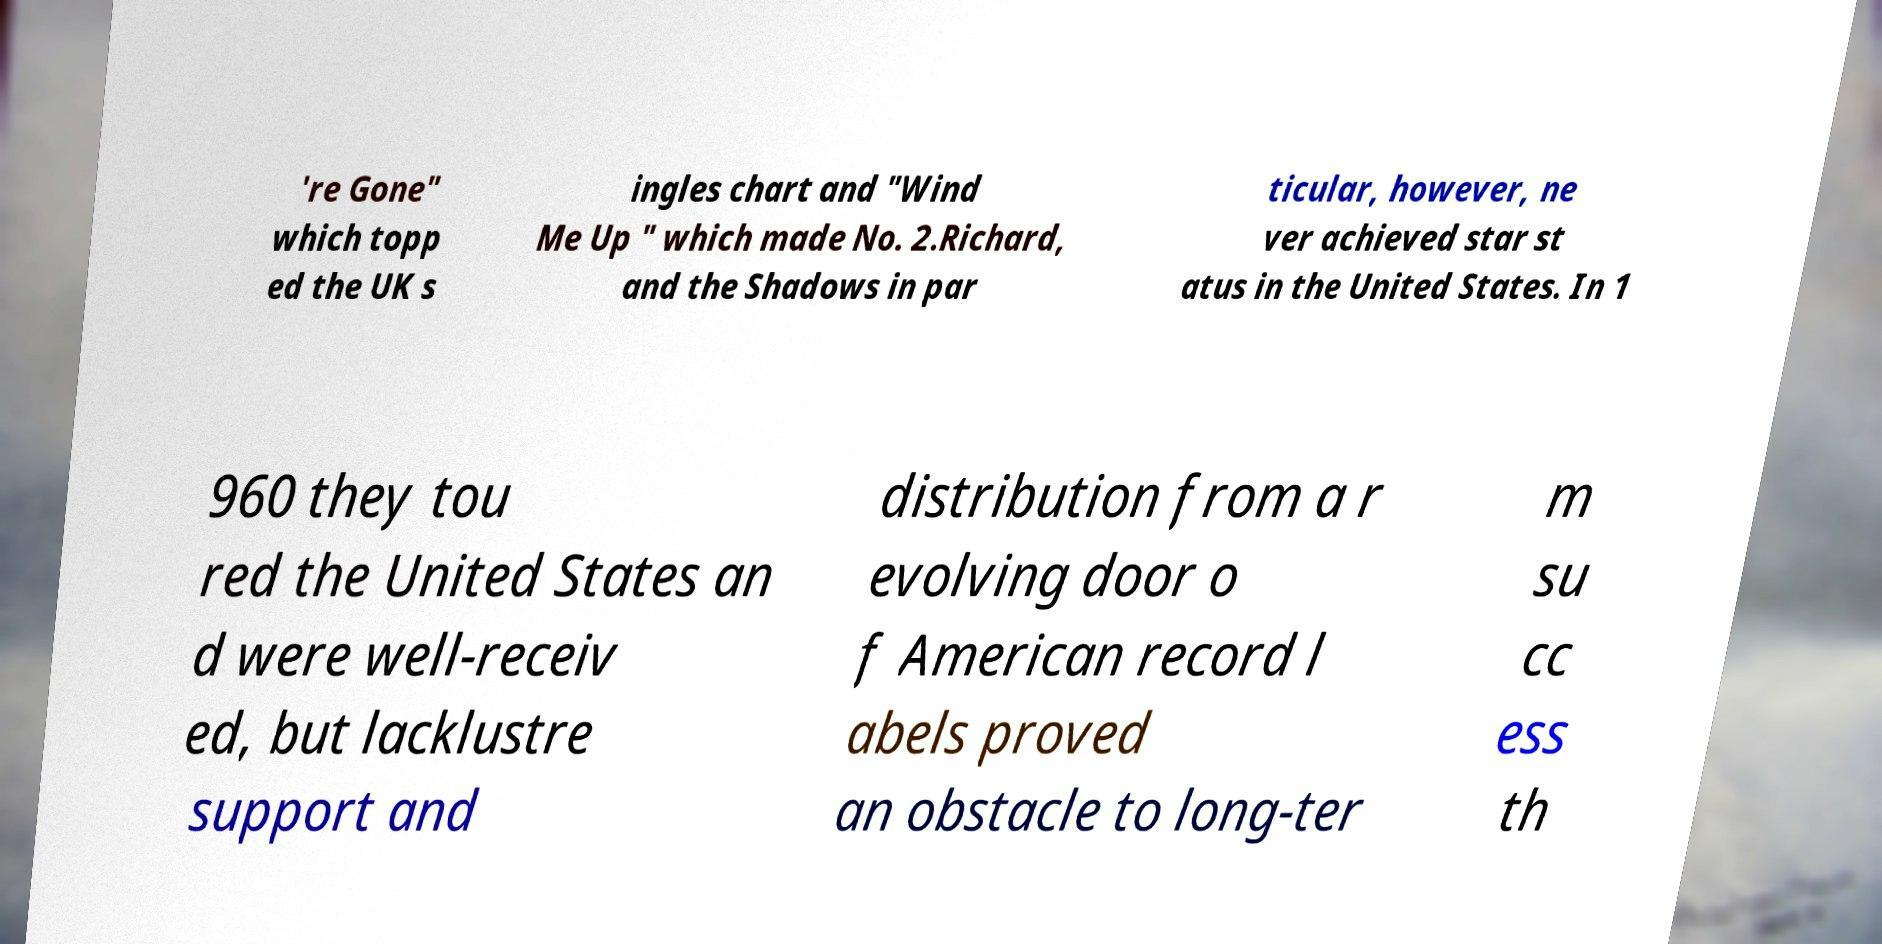There's text embedded in this image that I need extracted. Can you transcribe it verbatim? 're Gone" which topp ed the UK s ingles chart and "Wind Me Up " which made No. 2.Richard, and the Shadows in par ticular, however, ne ver achieved star st atus in the United States. In 1 960 they tou red the United States an d were well-receiv ed, but lacklustre support and distribution from a r evolving door o f American record l abels proved an obstacle to long-ter m su cc ess th 